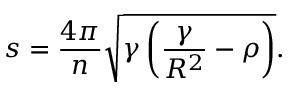<formula> <loc_0><loc_0><loc_500><loc_500>s = \frac { 4 \pi } { n } \sqrt { \gamma \left ( \frac { \gamma } { R ^ { 2 } } - \rho \right ) } .</formula> 